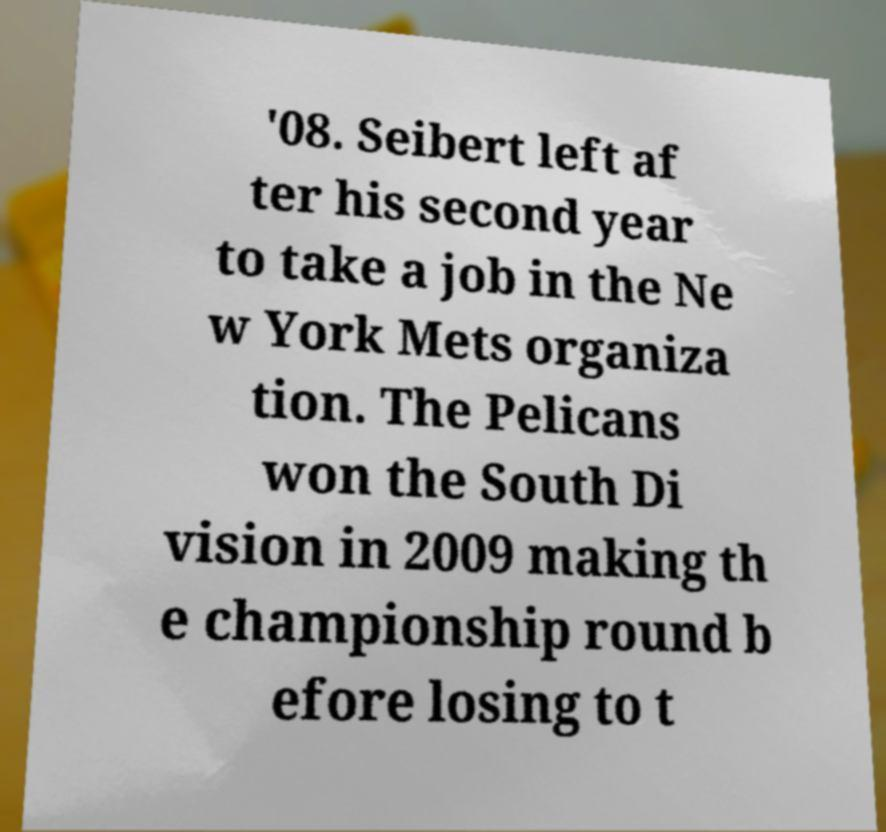What messages or text are displayed in this image? I need them in a readable, typed format. '08. Seibert left af ter his second year to take a job in the Ne w York Mets organiza tion. The Pelicans won the South Di vision in 2009 making th e championship round b efore losing to t 